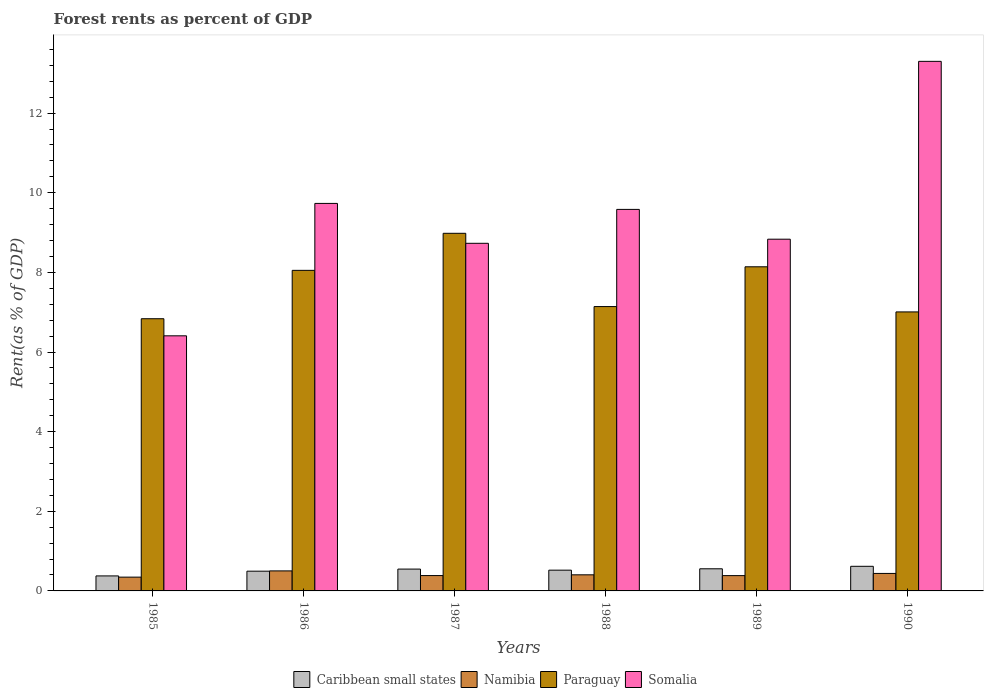Are the number of bars per tick equal to the number of legend labels?
Your response must be concise. Yes. How many bars are there on the 5th tick from the right?
Offer a very short reply. 4. In how many cases, is the number of bars for a given year not equal to the number of legend labels?
Your answer should be compact. 0. What is the forest rent in Caribbean small states in 1986?
Ensure brevity in your answer.  0.5. Across all years, what is the maximum forest rent in Paraguay?
Ensure brevity in your answer.  8.98. Across all years, what is the minimum forest rent in Somalia?
Offer a terse response. 6.41. In which year was the forest rent in Paraguay minimum?
Your answer should be very brief. 1985. What is the total forest rent in Paraguay in the graph?
Offer a terse response. 46.15. What is the difference between the forest rent in Caribbean small states in 1986 and that in 1989?
Give a very brief answer. -0.06. What is the difference between the forest rent in Caribbean small states in 1989 and the forest rent in Somalia in 1990?
Make the answer very short. -12.74. What is the average forest rent in Paraguay per year?
Your answer should be very brief. 7.69. In the year 1990, what is the difference between the forest rent in Namibia and forest rent in Somalia?
Offer a terse response. -12.86. In how many years, is the forest rent in Somalia greater than 3.6 %?
Provide a short and direct response. 6. What is the ratio of the forest rent in Paraguay in 1988 to that in 1989?
Ensure brevity in your answer.  0.88. Is the forest rent in Caribbean small states in 1986 less than that in 1988?
Your response must be concise. Yes. What is the difference between the highest and the second highest forest rent in Namibia?
Make the answer very short. 0.06. What is the difference between the highest and the lowest forest rent in Paraguay?
Your response must be concise. 2.15. Is the sum of the forest rent in Namibia in 1987 and 1989 greater than the maximum forest rent in Paraguay across all years?
Keep it short and to the point. No. What does the 3rd bar from the left in 1989 represents?
Your answer should be compact. Paraguay. What does the 4th bar from the right in 1988 represents?
Your response must be concise. Caribbean small states. What is the difference between two consecutive major ticks on the Y-axis?
Make the answer very short. 2. Are the values on the major ticks of Y-axis written in scientific E-notation?
Provide a short and direct response. No. Does the graph contain grids?
Make the answer very short. No. Where does the legend appear in the graph?
Ensure brevity in your answer.  Bottom center. How many legend labels are there?
Ensure brevity in your answer.  4. What is the title of the graph?
Your response must be concise. Forest rents as percent of GDP. What is the label or title of the X-axis?
Give a very brief answer. Years. What is the label or title of the Y-axis?
Offer a terse response. Rent(as % of GDP). What is the Rent(as % of GDP) of Caribbean small states in 1985?
Make the answer very short. 0.38. What is the Rent(as % of GDP) in Namibia in 1985?
Offer a terse response. 0.35. What is the Rent(as % of GDP) of Paraguay in 1985?
Offer a very short reply. 6.84. What is the Rent(as % of GDP) in Somalia in 1985?
Ensure brevity in your answer.  6.41. What is the Rent(as % of GDP) in Caribbean small states in 1986?
Offer a very short reply. 0.5. What is the Rent(as % of GDP) in Namibia in 1986?
Your answer should be compact. 0.5. What is the Rent(as % of GDP) in Paraguay in 1986?
Offer a very short reply. 8.05. What is the Rent(as % of GDP) of Somalia in 1986?
Give a very brief answer. 9.73. What is the Rent(as % of GDP) in Caribbean small states in 1987?
Your answer should be compact. 0.55. What is the Rent(as % of GDP) in Namibia in 1987?
Keep it short and to the point. 0.39. What is the Rent(as % of GDP) of Paraguay in 1987?
Keep it short and to the point. 8.98. What is the Rent(as % of GDP) of Somalia in 1987?
Ensure brevity in your answer.  8.73. What is the Rent(as % of GDP) of Caribbean small states in 1988?
Your response must be concise. 0.52. What is the Rent(as % of GDP) in Namibia in 1988?
Offer a terse response. 0.4. What is the Rent(as % of GDP) in Paraguay in 1988?
Your response must be concise. 7.14. What is the Rent(as % of GDP) of Somalia in 1988?
Provide a short and direct response. 9.58. What is the Rent(as % of GDP) of Caribbean small states in 1989?
Your answer should be very brief. 0.56. What is the Rent(as % of GDP) of Namibia in 1989?
Your answer should be compact. 0.38. What is the Rent(as % of GDP) of Paraguay in 1989?
Give a very brief answer. 8.14. What is the Rent(as % of GDP) in Somalia in 1989?
Offer a very short reply. 8.83. What is the Rent(as % of GDP) in Caribbean small states in 1990?
Provide a succinct answer. 0.62. What is the Rent(as % of GDP) in Namibia in 1990?
Give a very brief answer. 0.44. What is the Rent(as % of GDP) in Paraguay in 1990?
Your response must be concise. 7.01. What is the Rent(as % of GDP) in Somalia in 1990?
Make the answer very short. 13.3. Across all years, what is the maximum Rent(as % of GDP) in Caribbean small states?
Your answer should be compact. 0.62. Across all years, what is the maximum Rent(as % of GDP) in Namibia?
Your answer should be compact. 0.5. Across all years, what is the maximum Rent(as % of GDP) in Paraguay?
Keep it short and to the point. 8.98. Across all years, what is the maximum Rent(as % of GDP) of Somalia?
Give a very brief answer. 13.3. Across all years, what is the minimum Rent(as % of GDP) in Caribbean small states?
Give a very brief answer. 0.38. Across all years, what is the minimum Rent(as % of GDP) of Namibia?
Your answer should be compact. 0.35. Across all years, what is the minimum Rent(as % of GDP) of Paraguay?
Provide a succinct answer. 6.84. Across all years, what is the minimum Rent(as % of GDP) in Somalia?
Provide a succinct answer. 6.41. What is the total Rent(as % of GDP) in Caribbean small states in the graph?
Ensure brevity in your answer.  3.12. What is the total Rent(as % of GDP) of Namibia in the graph?
Offer a terse response. 2.46. What is the total Rent(as % of GDP) of Paraguay in the graph?
Give a very brief answer. 46.15. What is the total Rent(as % of GDP) in Somalia in the graph?
Offer a terse response. 56.58. What is the difference between the Rent(as % of GDP) of Caribbean small states in 1985 and that in 1986?
Your answer should be very brief. -0.12. What is the difference between the Rent(as % of GDP) of Namibia in 1985 and that in 1986?
Provide a short and direct response. -0.16. What is the difference between the Rent(as % of GDP) in Paraguay in 1985 and that in 1986?
Make the answer very short. -1.22. What is the difference between the Rent(as % of GDP) in Somalia in 1985 and that in 1986?
Ensure brevity in your answer.  -3.33. What is the difference between the Rent(as % of GDP) in Caribbean small states in 1985 and that in 1987?
Offer a very short reply. -0.17. What is the difference between the Rent(as % of GDP) of Namibia in 1985 and that in 1987?
Your answer should be very brief. -0.04. What is the difference between the Rent(as % of GDP) in Paraguay in 1985 and that in 1987?
Keep it short and to the point. -2.15. What is the difference between the Rent(as % of GDP) in Somalia in 1985 and that in 1987?
Ensure brevity in your answer.  -2.32. What is the difference between the Rent(as % of GDP) of Caribbean small states in 1985 and that in 1988?
Your answer should be compact. -0.14. What is the difference between the Rent(as % of GDP) in Namibia in 1985 and that in 1988?
Your answer should be very brief. -0.06. What is the difference between the Rent(as % of GDP) in Paraguay in 1985 and that in 1988?
Your answer should be compact. -0.31. What is the difference between the Rent(as % of GDP) in Somalia in 1985 and that in 1988?
Provide a succinct answer. -3.17. What is the difference between the Rent(as % of GDP) in Caribbean small states in 1985 and that in 1989?
Your response must be concise. -0.18. What is the difference between the Rent(as % of GDP) of Namibia in 1985 and that in 1989?
Provide a succinct answer. -0.04. What is the difference between the Rent(as % of GDP) in Paraguay in 1985 and that in 1989?
Provide a succinct answer. -1.3. What is the difference between the Rent(as % of GDP) in Somalia in 1985 and that in 1989?
Ensure brevity in your answer.  -2.43. What is the difference between the Rent(as % of GDP) in Caribbean small states in 1985 and that in 1990?
Give a very brief answer. -0.24. What is the difference between the Rent(as % of GDP) of Namibia in 1985 and that in 1990?
Keep it short and to the point. -0.09. What is the difference between the Rent(as % of GDP) of Paraguay in 1985 and that in 1990?
Your response must be concise. -0.17. What is the difference between the Rent(as % of GDP) of Somalia in 1985 and that in 1990?
Make the answer very short. -6.89. What is the difference between the Rent(as % of GDP) of Caribbean small states in 1986 and that in 1987?
Your response must be concise. -0.05. What is the difference between the Rent(as % of GDP) of Namibia in 1986 and that in 1987?
Give a very brief answer. 0.12. What is the difference between the Rent(as % of GDP) of Paraguay in 1986 and that in 1987?
Make the answer very short. -0.93. What is the difference between the Rent(as % of GDP) of Caribbean small states in 1986 and that in 1988?
Provide a succinct answer. -0.03. What is the difference between the Rent(as % of GDP) in Namibia in 1986 and that in 1988?
Your answer should be compact. 0.1. What is the difference between the Rent(as % of GDP) of Paraguay in 1986 and that in 1988?
Provide a short and direct response. 0.91. What is the difference between the Rent(as % of GDP) in Somalia in 1986 and that in 1988?
Your response must be concise. 0.15. What is the difference between the Rent(as % of GDP) of Caribbean small states in 1986 and that in 1989?
Give a very brief answer. -0.06. What is the difference between the Rent(as % of GDP) of Namibia in 1986 and that in 1989?
Your response must be concise. 0.12. What is the difference between the Rent(as % of GDP) in Paraguay in 1986 and that in 1989?
Your answer should be very brief. -0.09. What is the difference between the Rent(as % of GDP) of Somalia in 1986 and that in 1989?
Offer a very short reply. 0.9. What is the difference between the Rent(as % of GDP) in Caribbean small states in 1986 and that in 1990?
Make the answer very short. -0.12. What is the difference between the Rent(as % of GDP) in Namibia in 1986 and that in 1990?
Give a very brief answer. 0.06. What is the difference between the Rent(as % of GDP) in Paraguay in 1986 and that in 1990?
Provide a succinct answer. 1.04. What is the difference between the Rent(as % of GDP) in Somalia in 1986 and that in 1990?
Provide a succinct answer. -3.57. What is the difference between the Rent(as % of GDP) in Caribbean small states in 1987 and that in 1988?
Offer a terse response. 0.03. What is the difference between the Rent(as % of GDP) of Namibia in 1987 and that in 1988?
Your answer should be compact. -0.02. What is the difference between the Rent(as % of GDP) in Paraguay in 1987 and that in 1988?
Your answer should be compact. 1.84. What is the difference between the Rent(as % of GDP) of Somalia in 1987 and that in 1988?
Ensure brevity in your answer.  -0.85. What is the difference between the Rent(as % of GDP) in Caribbean small states in 1987 and that in 1989?
Provide a succinct answer. -0.01. What is the difference between the Rent(as % of GDP) of Namibia in 1987 and that in 1989?
Ensure brevity in your answer.  0. What is the difference between the Rent(as % of GDP) in Paraguay in 1987 and that in 1989?
Your response must be concise. 0.84. What is the difference between the Rent(as % of GDP) of Somalia in 1987 and that in 1989?
Make the answer very short. -0.1. What is the difference between the Rent(as % of GDP) of Caribbean small states in 1987 and that in 1990?
Give a very brief answer. -0.07. What is the difference between the Rent(as % of GDP) of Namibia in 1987 and that in 1990?
Provide a succinct answer. -0.05. What is the difference between the Rent(as % of GDP) of Paraguay in 1987 and that in 1990?
Offer a very short reply. 1.97. What is the difference between the Rent(as % of GDP) in Somalia in 1987 and that in 1990?
Make the answer very short. -4.57. What is the difference between the Rent(as % of GDP) of Caribbean small states in 1988 and that in 1989?
Your answer should be very brief. -0.03. What is the difference between the Rent(as % of GDP) of Namibia in 1988 and that in 1989?
Provide a succinct answer. 0.02. What is the difference between the Rent(as % of GDP) in Paraguay in 1988 and that in 1989?
Ensure brevity in your answer.  -1. What is the difference between the Rent(as % of GDP) in Somalia in 1988 and that in 1989?
Make the answer very short. 0.75. What is the difference between the Rent(as % of GDP) in Caribbean small states in 1988 and that in 1990?
Offer a terse response. -0.1. What is the difference between the Rent(as % of GDP) of Namibia in 1988 and that in 1990?
Ensure brevity in your answer.  -0.03. What is the difference between the Rent(as % of GDP) in Paraguay in 1988 and that in 1990?
Your answer should be compact. 0.13. What is the difference between the Rent(as % of GDP) of Somalia in 1988 and that in 1990?
Provide a short and direct response. -3.72. What is the difference between the Rent(as % of GDP) in Caribbean small states in 1989 and that in 1990?
Offer a terse response. -0.06. What is the difference between the Rent(as % of GDP) of Namibia in 1989 and that in 1990?
Your answer should be compact. -0.06. What is the difference between the Rent(as % of GDP) in Paraguay in 1989 and that in 1990?
Your answer should be compact. 1.13. What is the difference between the Rent(as % of GDP) of Somalia in 1989 and that in 1990?
Your answer should be compact. -4.47. What is the difference between the Rent(as % of GDP) in Caribbean small states in 1985 and the Rent(as % of GDP) in Namibia in 1986?
Give a very brief answer. -0.13. What is the difference between the Rent(as % of GDP) of Caribbean small states in 1985 and the Rent(as % of GDP) of Paraguay in 1986?
Provide a short and direct response. -7.67. What is the difference between the Rent(as % of GDP) of Caribbean small states in 1985 and the Rent(as % of GDP) of Somalia in 1986?
Provide a short and direct response. -9.35. What is the difference between the Rent(as % of GDP) in Namibia in 1985 and the Rent(as % of GDP) in Paraguay in 1986?
Offer a terse response. -7.7. What is the difference between the Rent(as % of GDP) in Namibia in 1985 and the Rent(as % of GDP) in Somalia in 1986?
Give a very brief answer. -9.39. What is the difference between the Rent(as % of GDP) in Paraguay in 1985 and the Rent(as % of GDP) in Somalia in 1986?
Your answer should be very brief. -2.9. What is the difference between the Rent(as % of GDP) of Caribbean small states in 1985 and the Rent(as % of GDP) of Namibia in 1987?
Your response must be concise. -0.01. What is the difference between the Rent(as % of GDP) in Caribbean small states in 1985 and the Rent(as % of GDP) in Paraguay in 1987?
Offer a very short reply. -8.6. What is the difference between the Rent(as % of GDP) in Caribbean small states in 1985 and the Rent(as % of GDP) in Somalia in 1987?
Give a very brief answer. -8.35. What is the difference between the Rent(as % of GDP) of Namibia in 1985 and the Rent(as % of GDP) of Paraguay in 1987?
Ensure brevity in your answer.  -8.63. What is the difference between the Rent(as % of GDP) of Namibia in 1985 and the Rent(as % of GDP) of Somalia in 1987?
Offer a terse response. -8.38. What is the difference between the Rent(as % of GDP) in Paraguay in 1985 and the Rent(as % of GDP) in Somalia in 1987?
Offer a terse response. -1.89. What is the difference between the Rent(as % of GDP) of Caribbean small states in 1985 and the Rent(as % of GDP) of Namibia in 1988?
Offer a terse response. -0.03. What is the difference between the Rent(as % of GDP) in Caribbean small states in 1985 and the Rent(as % of GDP) in Paraguay in 1988?
Your answer should be compact. -6.76. What is the difference between the Rent(as % of GDP) in Caribbean small states in 1985 and the Rent(as % of GDP) in Somalia in 1988?
Ensure brevity in your answer.  -9.2. What is the difference between the Rent(as % of GDP) of Namibia in 1985 and the Rent(as % of GDP) of Paraguay in 1988?
Provide a succinct answer. -6.79. What is the difference between the Rent(as % of GDP) in Namibia in 1985 and the Rent(as % of GDP) in Somalia in 1988?
Provide a short and direct response. -9.23. What is the difference between the Rent(as % of GDP) of Paraguay in 1985 and the Rent(as % of GDP) of Somalia in 1988?
Your answer should be very brief. -2.75. What is the difference between the Rent(as % of GDP) of Caribbean small states in 1985 and the Rent(as % of GDP) of Namibia in 1989?
Your answer should be very brief. -0.01. What is the difference between the Rent(as % of GDP) in Caribbean small states in 1985 and the Rent(as % of GDP) in Paraguay in 1989?
Provide a short and direct response. -7.76. What is the difference between the Rent(as % of GDP) of Caribbean small states in 1985 and the Rent(as % of GDP) of Somalia in 1989?
Your answer should be compact. -8.46. What is the difference between the Rent(as % of GDP) of Namibia in 1985 and the Rent(as % of GDP) of Paraguay in 1989?
Your answer should be compact. -7.79. What is the difference between the Rent(as % of GDP) of Namibia in 1985 and the Rent(as % of GDP) of Somalia in 1989?
Offer a very short reply. -8.49. What is the difference between the Rent(as % of GDP) in Paraguay in 1985 and the Rent(as % of GDP) in Somalia in 1989?
Make the answer very short. -2. What is the difference between the Rent(as % of GDP) in Caribbean small states in 1985 and the Rent(as % of GDP) in Namibia in 1990?
Your answer should be compact. -0.06. What is the difference between the Rent(as % of GDP) of Caribbean small states in 1985 and the Rent(as % of GDP) of Paraguay in 1990?
Provide a short and direct response. -6.63. What is the difference between the Rent(as % of GDP) of Caribbean small states in 1985 and the Rent(as % of GDP) of Somalia in 1990?
Your response must be concise. -12.92. What is the difference between the Rent(as % of GDP) of Namibia in 1985 and the Rent(as % of GDP) of Paraguay in 1990?
Make the answer very short. -6.66. What is the difference between the Rent(as % of GDP) of Namibia in 1985 and the Rent(as % of GDP) of Somalia in 1990?
Offer a very short reply. -12.95. What is the difference between the Rent(as % of GDP) of Paraguay in 1985 and the Rent(as % of GDP) of Somalia in 1990?
Make the answer very short. -6.46. What is the difference between the Rent(as % of GDP) in Caribbean small states in 1986 and the Rent(as % of GDP) in Namibia in 1987?
Offer a terse response. 0.11. What is the difference between the Rent(as % of GDP) of Caribbean small states in 1986 and the Rent(as % of GDP) of Paraguay in 1987?
Make the answer very short. -8.49. What is the difference between the Rent(as % of GDP) in Caribbean small states in 1986 and the Rent(as % of GDP) in Somalia in 1987?
Ensure brevity in your answer.  -8.23. What is the difference between the Rent(as % of GDP) of Namibia in 1986 and the Rent(as % of GDP) of Paraguay in 1987?
Provide a succinct answer. -8.48. What is the difference between the Rent(as % of GDP) in Namibia in 1986 and the Rent(as % of GDP) in Somalia in 1987?
Offer a terse response. -8.23. What is the difference between the Rent(as % of GDP) in Paraguay in 1986 and the Rent(as % of GDP) in Somalia in 1987?
Provide a short and direct response. -0.68. What is the difference between the Rent(as % of GDP) in Caribbean small states in 1986 and the Rent(as % of GDP) in Namibia in 1988?
Offer a very short reply. 0.09. What is the difference between the Rent(as % of GDP) in Caribbean small states in 1986 and the Rent(as % of GDP) in Paraguay in 1988?
Offer a terse response. -6.65. What is the difference between the Rent(as % of GDP) in Caribbean small states in 1986 and the Rent(as % of GDP) in Somalia in 1988?
Offer a very short reply. -9.09. What is the difference between the Rent(as % of GDP) in Namibia in 1986 and the Rent(as % of GDP) in Paraguay in 1988?
Your answer should be very brief. -6.64. What is the difference between the Rent(as % of GDP) in Namibia in 1986 and the Rent(as % of GDP) in Somalia in 1988?
Ensure brevity in your answer.  -9.08. What is the difference between the Rent(as % of GDP) of Paraguay in 1986 and the Rent(as % of GDP) of Somalia in 1988?
Provide a succinct answer. -1.53. What is the difference between the Rent(as % of GDP) in Caribbean small states in 1986 and the Rent(as % of GDP) in Namibia in 1989?
Provide a succinct answer. 0.11. What is the difference between the Rent(as % of GDP) in Caribbean small states in 1986 and the Rent(as % of GDP) in Paraguay in 1989?
Offer a terse response. -7.64. What is the difference between the Rent(as % of GDP) in Caribbean small states in 1986 and the Rent(as % of GDP) in Somalia in 1989?
Ensure brevity in your answer.  -8.34. What is the difference between the Rent(as % of GDP) of Namibia in 1986 and the Rent(as % of GDP) of Paraguay in 1989?
Make the answer very short. -7.64. What is the difference between the Rent(as % of GDP) in Namibia in 1986 and the Rent(as % of GDP) in Somalia in 1989?
Your answer should be very brief. -8.33. What is the difference between the Rent(as % of GDP) of Paraguay in 1986 and the Rent(as % of GDP) of Somalia in 1989?
Keep it short and to the point. -0.78. What is the difference between the Rent(as % of GDP) of Caribbean small states in 1986 and the Rent(as % of GDP) of Namibia in 1990?
Your answer should be very brief. 0.06. What is the difference between the Rent(as % of GDP) in Caribbean small states in 1986 and the Rent(as % of GDP) in Paraguay in 1990?
Give a very brief answer. -6.51. What is the difference between the Rent(as % of GDP) in Caribbean small states in 1986 and the Rent(as % of GDP) in Somalia in 1990?
Offer a terse response. -12.8. What is the difference between the Rent(as % of GDP) of Namibia in 1986 and the Rent(as % of GDP) of Paraguay in 1990?
Offer a very short reply. -6.5. What is the difference between the Rent(as % of GDP) of Namibia in 1986 and the Rent(as % of GDP) of Somalia in 1990?
Provide a short and direct response. -12.8. What is the difference between the Rent(as % of GDP) in Paraguay in 1986 and the Rent(as % of GDP) in Somalia in 1990?
Ensure brevity in your answer.  -5.25. What is the difference between the Rent(as % of GDP) in Caribbean small states in 1987 and the Rent(as % of GDP) in Namibia in 1988?
Your answer should be very brief. 0.14. What is the difference between the Rent(as % of GDP) of Caribbean small states in 1987 and the Rent(as % of GDP) of Paraguay in 1988?
Offer a very short reply. -6.59. What is the difference between the Rent(as % of GDP) of Caribbean small states in 1987 and the Rent(as % of GDP) of Somalia in 1988?
Ensure brevity in your answer.  -9.03. What is the difference between the Rent(as % of GDP) of Namibia in 1987 and the Rent(as % of GDP) of Paraguay in 1988?
Offer a terse response. -6.76. What is the difference between the Rent(as % of GDP) in Namibia in 1987 and the Rent(as % of GDP) in Somalia in 1988?
Your answer should be very brief. -9.2. What is the difference between the Rent(as % of GDP) in Paraguay in 1987 and the Rent(as % of GDP) in Somalia in 1988?
Your answer should be compact. -0.6. What is the difference between the Rent(as % of GDP) of Caribbean small states in 1987 and the Rent(as % of GDP) of Namibia in 1989?
Ensure brevity in your answer.  0.16. What is the difference between the Rent(as % of GDP) in Caribbean small states in 1987 and the Rent(as % of GDP) in Paraguay in 1989?
Your answer should be very brief. -7.59. What is the difference between the Rent(as % of GDP) in Caribbean small states in 1987 and the Rent(as % of GDP) in Somalia in 1989?
Offer a terse response. -8.28. What is the difference between the Rent(as % of GDP) of Namibia in 1987 and the Rent(as % of GDP) of Paraguay in 1989?
Offer a terse response. -7.75. What is the difference between the Rent(as % of GDP) in Namibia in 1987 and the Rent(as % of GDP) in Somalia in 1989?
Your answer should be compact. -8.45. What is the difference between the Rent(as % of GDP) of Paraguay in 1987 and the Rent(as % of GDP) of Somalia in 1989?
Provide a short and direct response. 0.15. What is the difference between the Rent(as % of GDP) of Caribbean small states in 1987 and the Rent(as % of GDP) of Namibia in 1990?
Make the answer very short. 0.11. What is the difference between the Rent(as % of GDP) in Caribbean small states in 1987 and the Rent(as % of GDP) in Paraguay in 1990?
Your answer should be very brief. -6.46. What is the difference between the Rent(as % of GDP) in Caribbean small states in 1987 and the Rent(as % of GDP) in Somalia in 1990?
Offer a terse response. -12.75. What is the difference between the Rent(as % of GDP) in Namibia in 1987 and the Rent(as % of GDP) in Paraguay in 1990?
Offer a very short reply. -6.62. What is the difference between the Rent(as % of GDP) in Namibia in 1987 and the Rent(as % of GDP) in Somalia in 1990?
Your answer should be very brief. -12.91. What is the difference between the Rent(as % of GDP) in Paraguay in 1987 and the Rent(as % of GDP) in Somalia in 1990?
Offer a very short reply. -4.32. What is the difference between the Rent(as % of GDP) in Caribbean small states in 1988 and the Rent(as % of GDP) in Namibia in 1989?
Provide a short and direct response. 0.14. What is the difference between the Rent(as % of GDP) of Caribbean small states in 1988 and the Rent(as % of GDP) of Paraguay in 1989?
Offer a terse response. -7.62. What is the difference between the Rent(as % of GDP) in Caribbean small states in 1988 and the Rent(as % of GDP) in Somalia in 1989?
Your answer should be compact. -8.31. What is the difference between the Rent(as % of GDP) in Namibia in 1988 and the Rent(as % of GDP) in Paraguay in 1989?
Your answer should be very brief. -7.74. What is the difference between the Rent(as % of GDP) in Namibia in 1988 and the Rent(as % of GDP) in Somalia in 1989?
Your answer should be compact. -8.43. What is the difference between the Rent(as % of GDP) in Paraguay in 1988 and the Rent(as % of GDP) in Somalia in 1989?
Provide a short and direct response. -1.69. What is the difference between the Rent(as % of GDP) in Caribbean small states in 1988 and the Rent(as % of GDP) in Namibia in 1990?
Give a very brief answer. 0.08. What is the difference between the Rent(as % of GDP) in Caribbean small states in 1988 and the Rent(as % of GDP) in Paraguay in 1990?
Make the answer very short. -6.49. What is the difference between the Rent(as % of GDP) of Caribbean small states in 1988 and the Rent(as % of GDP) of Somalia in 1990?
Ensure brevity in your answer.  -12.78. What is the difference between the Rent(as % of GDP) of Namibia in 1988 and the Rent(as % of GDP) of Paraguay in 1990?
Provide a succinct answer. -6.6. What is the difference between the Rent(as % of GDP) in Namibia in 1988 and the Rent(as % of GDP) in Somalia in 1990?
Provide a short and direct response. -12.89. What is the difference between the Rent(as % of GDP) in Paraguay in 1988 and the Rent(as % of GDP) in Somalia in 1990?
Provide a short and direct response. -6.16. What is the difference between the Rent(as % of GDP) in Caribbean small states in 1989 and the Rent(as % of GDP) in Namibia in 1990?
Make the answer very short. 0.12. What is the difference between the Rent(as % of GDP) in Caribbean small states in 1989 and the Rent(as % of GDP) in Paraguay in 1990?
Your response must be concise. -6.45. What is the difference between the Rent(as % of GDP) of Caribbean small states in 1989 and the Rent(as % of GDP) of Somalia in 1990?
Your answer should be very brief. -12.74. What is the difference between the Rent(as % of GDP) of Namibia in 1989 and the Rent(as % of GDP) of Paraguay in 1990?
Offer a very short reply. -6.62. What is the difference between the Rent(as % of GDP) of Namibia in 1989 and the Rent(as % of GDP) of Somalia in 1990?
Provide a succinct answer. -12.91. What is the difference between the Rent(as % of GDP) of Paraguay in 1989 and the Rent(as % of GDP) of Somalia in 1990?
Offer a terse response. -5.16. What is the average Rent(as % of GDP) in Caribbean small states per year?
Provide a succinct answer. 0.52. What is the average Rent(as % of GDP) of Namibia per year?
Offer a terse response. 0.41. What is the average Rent(as % of GDP) in Paraguay per year?
Your response must be concise. 7.69. What is the average Rent(as % of GDP) of Somalia per year?
Your answer should be very brief. 9.43. In the year 1985, what is the difference between the Rent(as % of GDP) of Caribbean small states and Rent(as % of GDP) of Namibia?
Make the answer very short. 0.03. In the year 1985, what is the difference between the Rent(as % of GDP) of Caribbean small states and Rent(as % of GDP) of Paraguay?
Make the answer very short. -6.46. In the year 1985, what is the difference between the Rent(as % of GDP) of Caribbean small states and Rent(as % of GDP) of Somalia?
Offer a very short reply. -6.03. In the year 1985, what is the difference between the Rent(as % of GDP) of Namibia and Rent(as % of GDP) of Paraguay?
Make the answer very short. -6.49. In the year 1985, what is the difference between the Rent(as % of GDP) of Namibia and Rent(as % of GDP) of Somalia?
Make the answer very short. -6.06. In the year 1985, what is the difference between the Rent(as % of GDP) of Paraguay and Rent(as % of GDP) of Somalia?
Give a very brief answer. 0.43. In the year 1986, what is the difference between the Rent(as % of GDP) in Caribbean small states and Rent(as % of GDP) in Namibia?
Offer a very short reply. -0.01. In the year 1986, what is the difference between the Rent(as % of GDP) of Caribbean small states and Rent(as % of GDP) of Paraguay?
Your answer should be very brief. -7.55. In the year 1986, what is the difference between the Rent(as % of GDP) in Caribbean small states and Rent(as % of GDP) in Somalia?
Offer a terse response. -9.24. In the year 1986, what is the difference between the Rent(as % of GDP) in Namibia and Rent(as % of GDP) in Paraguay?
Offer a terse response. -7.55. In the year 1986, what is the difference between the Rent(as % of GDP) of Namibia and Rent(as % of GDP) of Somalia?
Give a very brief answer. -9.23. In the year 1986, what is the difference between the Rent(as % of GDP) of Paraguay and Rent(as % of GDP) of Somalia?
Keep it short and to the point. -1.68. In the year 1987, what is the difference between the Rent(as % of GDP) in Caribbean small states and Rent(as % of GDP) in Namibia?
Provide a succinct answer. 0.16. In the year 1987, what is the difference between the Rent(as % of GDP) in Caribbean small states and Rent(as % of GDP) in Paraguay?
Offer a terse response. -8.43. In the year 1987, what is the difference between the Rent(as % of GDP) in Caribbean small states and Rent(as % of GDP) in Somalia?
Keep it short and to the point. -8.18. In the year 1987, what is the difference between the Rent(as % of GDP) of Namibia and Rent(as % of GDP) of Paraguay?
Provide a short and direct response. -8.6. In the year 1987, what is the difference between the Rent(as % of GDP) of Namibia and Rent(as % of GDP) of Somalia?
Make the answer very short. -8.34. In the year 1987, what is the difference between the Rent(as % of GDP) of Paraguay and Rent(as % of GDP) of Somalia?
Your answer should be compact. 0.25. In the year 1988, what is the difference between the Rent(as % of GDP) of Caribbean small states and Rent(as % of GDP) of Namibia?
Keep it short and to the point. 0.12. In the year 1988, what is the difference between the Rent(as % of GDP) in Caribbean small states and Rent(as % of GDP) in Paraguay?
Provide a short and direct response. -6.62. In the year 1988, what is the difference between the Rent(as % of GDP) of Caribbean small states and Rent(as % of GDP) of Somalia?
Ensure brevity in your answer.  -9.06. In the year 1988, what is the difference between the Rent(as % of GDP) in Namibia and Rent(as % of GDP) in Paraguay?
Make the answer very short. -6.74. In the year 1988, what is the difference between the Rent(as % of GDP) of Namibia and Rent(as % of GDP) of Somalia?
Offer a terse response. -9.18. In the year 1988, what is the difference between the Rent(as % of GDP) of Paraguay and Rent(as % of GDP) of Somalia?
Ensure brevity in your answer.  -2.44. In the year 1989, what is the difference between the Rent(as % of GDP) of Caribbean small states and Rent(as % of GDP) of Namibia?
Your answer should be very brief. 0.17. In the year 1989, what is the difference between the Rent(as % of GDP) of Caribbean small states and Rent(as % of GDP) of Paraguay?
Provide a short and direct response. -7.58. In the year 1989, what is the difference between the Rent(as % of GDP) of Caribbean small states and Rent(as % of GDP) of Somalia?
Your answer should be very brief. -8.28. In the year 1989, what is the difference between the Rent(as % of GDP) of Namibia and Rent(as % of GDP) of Paraguay?
Keep it short and to the point. -7.76. In the year 1989, what is the difference between the Rent(as % of GDP) of Namibia and Rent(as % of GDP) of Somalia?
Your answer should be very brief. -8.45. In the year 1989, what is the difference between the Rent(as % of GDP) in Paraguay and Rent(as % of GDP) in Somalia?
Your answer should be very brief. -0.69. In the year 1990, what is the difference between the Rent(as % of GDP) of Caribbean small states and Rent(as % of GDP) of Namibia?
Your response must be concise. 0.18. In the year 1990, what is the difference between the Rent(as % of GDP) in Caribbean small states and Rent(as % of GDP) in Paraguay?
Your answer should be very brief. -6.39. In the year 1990, what is the difference between the Rent(as % of GDP) of Caribbean small states and Rent(as % of GDP) of Somalia?
Give a very brief answer. -12.68. In the year 1990, what is the difference between the Rent(as % of GDP) of Namibia and Rent(as % of GDP) of Paraguay?
Your answer should be compact. -6.57. In the year 1990, what is the difference between the Rent(as % of GDP) of Namibia and Rent(as % of GDP) of Somalia?
Your answer should be compact. -12.86. In the year 1990, what is the difference between the Rent(as % of GDP) in Paraguay and Rent(as % of GDP) in Somalia?
Make the answer very short. -6.29. What is the ratio of the Rent(as % of GDP) in Caribbean small states in 1985 to that in 1986?
Keep it short and to the point. 0.76. What is the ratio of the Rent(as % of GDP) of Namibia in 1985 to that in 1986?
Provide a succinct answer. 0.69. What is the ratio of the Rent(as % of GDP) in Paraguay in 1985 to that in 1986?
Offer a very short reply. 0.85. What is the ratio of the Rent(as % of GDP) in Somalia in 1985 to that in 1986?
Provide a succinct answer. 0.66. What is the ratio of the Rent(as % of GDP) of Caribbean small states in 1985 to that in 1987?
Provide a short and direct response. 0.69. What is the ratio of the Rent(as % of GDP) of Namibia in 1985 to that in 1987?
Your answer should be very brief. 0.9. What is the ratio of the Rent(as % of GDP) in Paraguay in 1985 to that in 1987?
Make the answer very short. 0.76. What is the ratio of the Rent(as % of GDP) of Somalia in 1985 to that in 1987?
Provide a succinct answer. 0.73. What is the ratio of the Rent(as % of GDP) of Caribbean small states in 1985 to that in 1988?
Offer a very short reply. 0.72. What is the ratio of the Rent(as % of GDP) of Namibia in 1985 to that in 1988?
Make the answer very short. 0.86. What is the ratio of the Rent(as % of GDP) in Paraguay in 1985 to that in 1988?
Offer a very short reply. 0.96. What is the ratio of the Rent(as % of GDP) of Somalia in 1985 to that in 1988?
Ensure brevity in your answer.  0.67. What is the ratio of the Rent(as % of GDP) of Caribbean small states in 1985 to that in 1989?
Make the answer very short. 0.68. What is the ratio of the Rent(as % of GDP) in Namibia in 1985 to that in 1989?
Your response must be concise. 0.9. What is the ratio of the Rent(as % of GDP) in Paraguay in 1985 to that in 1989?
Your response must be concise. 0.84. What is the ratio of the Rent(as % of GDP) in Somalia in 1985 to that in 1989?
Make the answer very short. 0.73. What is the ratio of the Rent(as % of GDP) in Caribbean small states in 1985 to that in 1990?
Your answer should be very brief. 0.61. What is the ratio of the Rent(as % of GDP) of Namibia in 1985 to that in 1990?
Your response must be concise. 0.79. What is the ratio of the Rent(as % of GDP) of Paraguay in 1985 to that in 1990?
Keep it short and to the point. 0.98. What is the ratio of the Rent(as % of GDP) of Somalia in 1985 to that in 1990?
Offer a very short reply. 0.48. What is the ratio of the Rent(as % of GDP) in Caribbean small states in 1986 to that in 1987?
Offer a very short reply. 0.9. What is the ratio of the Rent(as % of GDP) in Namibia in 1986 to that in 1987?
Offer a very short reply. 1.3. What is the ratio of the Rent(as % of GDP) of Paraguay in 1986 to that in 1987?
Offer a very short reply. 0.9. What is the ratio of the Rent(as % of GDP) in Somalia in 1986 to that in 1987?
Provide a short and direct response. 1.11. What is the ratio of the Rent(as % of GDP) of Caribbean small states in 1986 to that in 1988?
Make the answer very short. 0.95. What is the ratio of the Rent(as % of GDP) in Namibia in 1986 to that in 1988?
Make the answer very short. 1.24. What is the ratio of the Rent(as % of GDP) in Paraguay in 1986 to that in 1988?
Make the answer very short. 1.13. What is the ratio of the Rent(as % of GDP) in Somalia in 1986 to that in 1988?
Your answer should be compact. 1.02. What is the ratio of the Rent(as % of GDP) of Caribbean small states in 1986 to that in 1989?
Your answer should be compact. 0.89. What is the ratio of the Rent(as % of GDP) in Namibia in 1986 to that in 1989?
Offer a terse response. 1.31. What is the ratio of the Rent(as % of GDP) in Paraguay in 1986 to that in 1989?
Provide a succinct answer. 0.99. What is the ratio of the Rent(as % of GDP) of Somalia in 1986 to that in 1989?
Ensure brevity in your answer.  1.1. What is the ratio of the Rent(as % of GDP) in Caribbean small states in 1986 to that in 1990?
Your answer should be compact. 0.8. What is the ratio of the Rent(as % of GDP) in Namibia in 1986 to that in 1990?
Make the answer very short. 1.15. What is the ratio of the Rent(as % of GDP) of Paraguay in 1986 to that in 1990?
Make the answer very short. 1.15. What is the ratio of the Rent(as % of GDP) of Somalia in 1986 to that in 1990?
Keep it short and to the point. 0.73. What is the ratio of the Rent(as % of GDP) in Caribbean small states in 1987 to that in 1988?
Offer a very short reply. 1.05. What is the ratio of the Rent(as % of GDP) of Namibia in 1987 to that in 1988?
Offer a terse response. 0.95. What is the ratio of the Rent(as % of GDP) in Paraguay in 1987 to that in 1988?
Make the answer very short. 1.26. What is the ratio of the Rent(as % of GDP) of Somalia in 1987 to that in 1988?
Keep it short and to the point. 0.91. What is the ratio of the Rent(as % of GDP) in Caribbean small states in 1987 to that in 1989?
Offer a terse response. 0.99. What is the ratio of the Rent(as % of GDP) of Namibia in 1987 to that in 1989?
Provide a short and direct response. 1. What is the ratio of the Rent(as % of GDP) of Paraguay in 1987 to that in 1989?
Your response must be concise. 1.1. What is the ratio of the Rent(as % of GDP) in Somalia in 1987 to that in 1989?
Keep it short and to the point. 0.99. What is the ratio of the Rent(as % of GDP) in Caribbean small states in 1987 to that in 1990?
Make the answer very short. 0.89. What is the ratio of the Rent(as % of GDP) of Namibia in 1987 to that in 1990?
Ensure brevity in your answer.  0.88. What is the ratio of the Rent(as % of GDP) in Paraguay in 1987 to that in 1990?
Provide a short and direct response. 1.28. What is the ratio of the Rent(as % of GDP) of Somalia in 1987 to that in 1990?
Keep it short and to the point. 0.66. What is the ratio of the Rent(as % of GDP) in Caribbean small states in 1988 to that in 1989?
Make the answer very short. 0.94. What is the ratio of the Rent(as % of GDP) in Namibia in 1988 to that in 1989?
Provide a succinct answer. 1.05. What is the ratio of the Rent(as % of GDP) in Paraguay in 1988 to that in 1989?
Your answer should be compact. 0.88. What is the ratio of the Rent(as % of GDP) in Somalia in 1988 to that in 1989?
Provide a succinct answer. 1.08. What is the ratio of the Rent(as % of GDP) in Caribbean small states in 1988 to that in 1990?
Give a very brief answer. 0.84. What is the ratio of the Rent(as % of GDP) of Namibia in 1988 to that in 1990?
Give a very brief answer. 0.92. What is the ratio of the Rent(as % of GDP) in Paraguay in 1988 to that in 1990?
Offer a very short reply. 1.02. What is the ratio of the Rent(as % of GDP) of Somalia in 1988 to that in 1990?
Your answer should be very brief. 0.72. What is the ratio of the Rent(as % of GDP) in Caribbean small states in 1989 to that in 1990?
Give a very brief answer. 0.9. What is the ratio of the Rent(as % of GDP) of Namibia in 1989 to that in 1990?
Your response must be concise. 0.87. What is the ratio of the Rent(as % of GDP) of Paraguay in 1989 to that in 1990?
Provide a short and direct response. 1.16. What is the ratio of the Rent(as % of GDP) of Somalia in 1989 to that in 1990?
Ensure brevity in your answer.  0.66. What is the difference between the highest and the second highest Rent(as % of GDP) of Caribbean small states?
Your response must be concise. 0.06. What is the difference between the highest and the second highest Rent(as % of GDP) of Namibia?
Offer a very short reply. 0.06. What is the difference between the highest and the second highest Rent(as % of GDP) in Paraguay?
Give a very brief answer. 0.84. What is the difference between the highest and the second highest Rent(as % of GDP) in Somalia?
Give a very brief answer. 3.57. What is the difference between the highest and the lowest Rent(as % of GDP) in Caribbean small states?
Your response must be concise. 0.24. What is the difference between the highest and the lowest Rent(as % of GDP) of Namibia?
Keep it short and to the point. 0.16. What is the difference between the highest and the lowest Rent(as % of GDP) of Paraguay?
Offer a very short reply. 2.15. What is the difference between the highest and the lowest Rent(as % of GDP) in Somalia?
Your response must be concise. 6.89. 